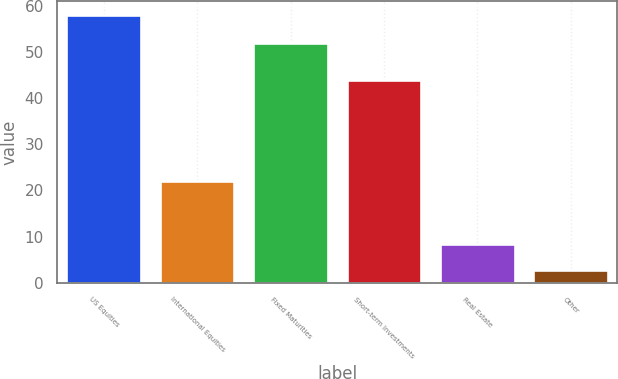<chart> <loc_0><loc_0><loc_500><loc_500><bar_chart><fcel>US Equities<fcel>International Equities<fcel>Fixed Maturities<fcel>Short-term Investments<fcel>Real Estate<fcel>Other<nl><fcel>58<fcel>22<fcel>52<fcel>44<fcel>8.37<fcel>2.85<nl></chart> 